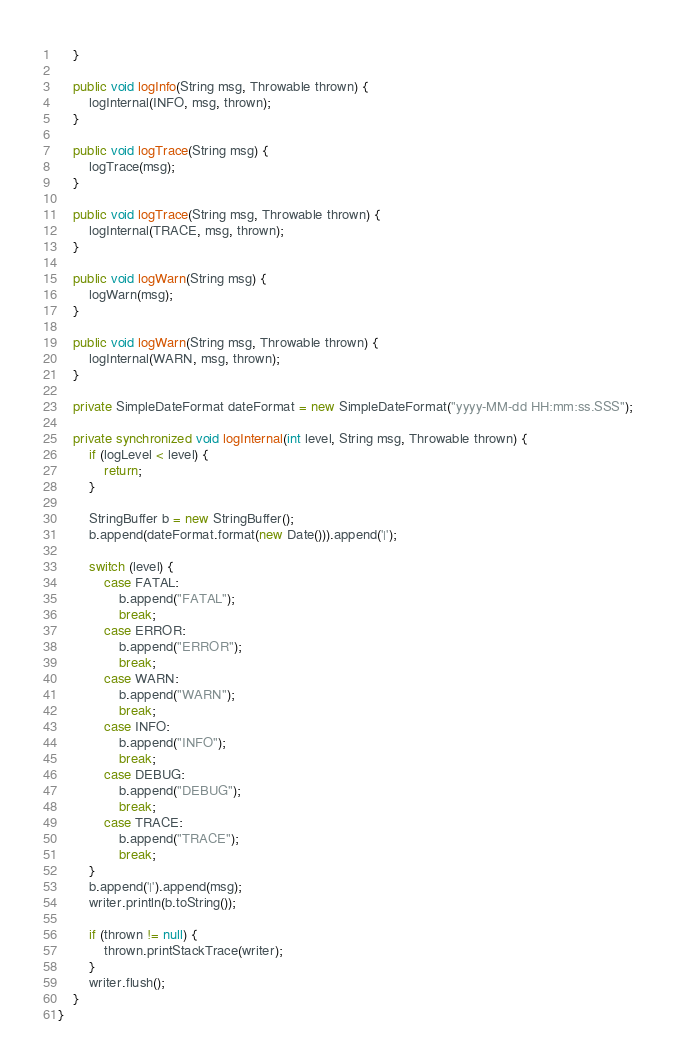Convert code to text. <code><loc_0><loc_0><loc_500><loc_500><_Java_>    }

    public void logInfo(String msg, Throwable thrown) {
        logInternal(INFO, msg, thrown);
    }

    public void logTrace(String msg) {
        logTrace(msg);
    }

    public void logTrace(String msg, Throwable thrown) {
        logInternal(TRACE, msg, thrown);
    }

    public void logWarn(String msg) {
        logWarn(msg);
    }

    public void logWarn(String msg, Throwable thrown) {
        logInternal(WARN, msg, thrown);
    }

    private SimpleDateFormat dateFormat = new SimpleDateFormat("yyyy-MM-dd HH:mm:ss.SSS");

    private synchronized void logInternal(int level, String msg, Throwable thrown) {
        if (logLevel < level) {
            return;
        }

        StringBuffer b = new StringBuffer();
        b.append(dateFormat.format(new Date())).append('|');

        switch (level) {
            case FATAL:
                b.append("FATAL");
                break;
            case ERROR:
                b.append("ERROR");
                break;
            case WARN:
                b.append("WARN");
                break;
            case INFO:
                b.append("INFO");
                break;
            case DEBUG:
                b.append("DEBUG");
                break;
            case TRACE:
                b.append("TRACE");
                break;
        }
        b.append('|').append(msg);
        writer.println(b.toString());

        if (thrown != null) {
            thrown.printStackTrace(writer);
        }
        writer.flush();
    }
}
</code> 